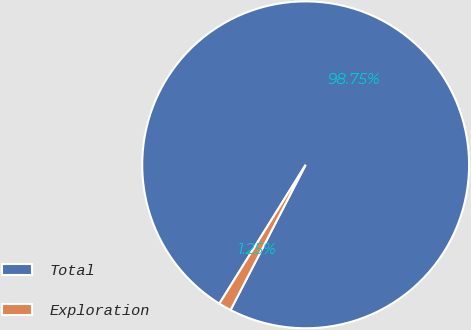Convert chart to OTSL. <chart><loc_0><loc_0><loc_500><loc_500><pie_chart><fcel>Total<fcel>Exploration<nl><fcel>98.75%<fcel>1.25%<nl></chart> 